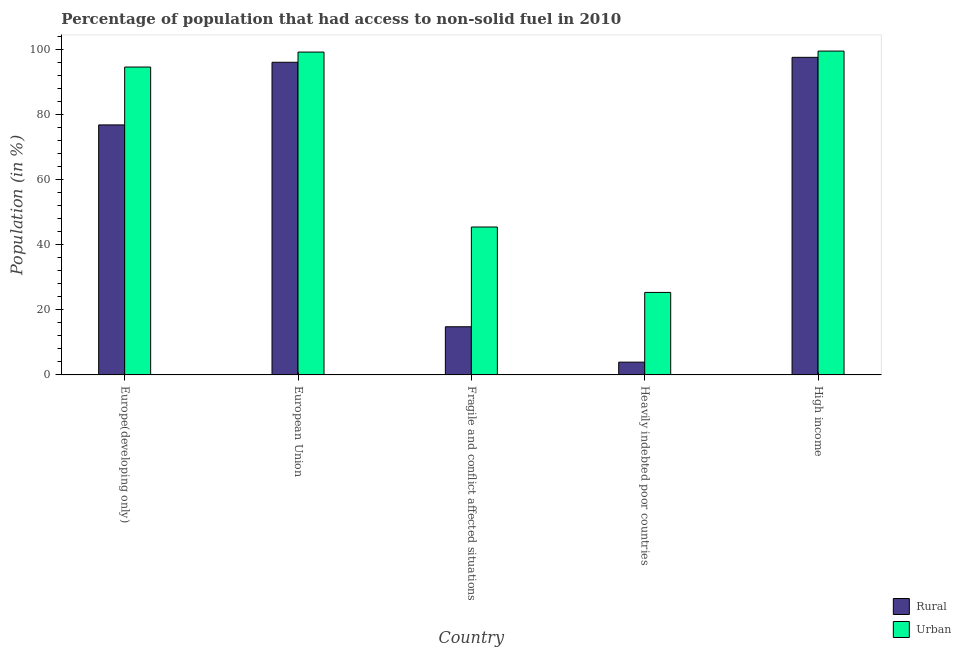How many groups of bars are there?
Your response must be concise. 5. How many bars are there on the 5th tick from the left?
Your answer should be very brief. 2. How many bars are there on the 5th tick from the right?
Your answer should be compact. 2. What is the urban population in European Union?
Keep it short and to the point. 99.33. Across all countries, what is the maximum urban population?
Your response must be concise. 99.63. Across all countries, what is the minimum rural population?
Keep it short and to the point. 3.93. In which country was the urban population maximum?
Offer a terse response. High income. In which country was the urban population minimum?
Keep it short and to the point. Heavily indebted poor countries. What is the total rural population in the graph?
Make the answer very short. 289.55. What is the difference between the urban population in European Union and that in Heavily indebted poor countries?
Offer a very short reply. 73.95. What is the difference between the urban population in European Union and the rural population in High income?
Offer a terse response. 1.62. What is the average rural population per country?
Provide a short and direct response. 57.91. What is the difference between the urban population and rural population in Fragile and conflict affected situations?
Give a very brief answer. 30.69. What is the ratio of the urban population in Fragile and conflict affected situations to that in High income?
Ensure brevity in your answer.  0.46. Is the difference between the urban population in European Union and Fragile and conflict affected situations greater than the difference between the rural population in European Union and Fragile and conflict affected situations?
Keep it short and to the point. No. What is the difference between the highest and the second highest urban population?
Offer a very short reply. 0.31. What is the difference between the highest and the lowest rural population?
Provide a short and direct response. 93.78. In how many countries, is the urban population greater than the average urban population taken over all countries?
Keep it short and to the point. 3. Is the sum of the rural population in Europe(developing only) and European Union greater than the maximum urban population across all countries?
Provide a short and direct response. Yes. What does the 1st bar from the left in Europe(developing only) represents?
Offer a terse response. Rural. What does the 2nd bar from the right in High income represents?
Offer a very short reply. Rural. Are all the bars in the graph horizontal?
Give a very brief answer. No. How many countries are there in the graph?
Keep it short and to the point. 5. Are the values on the major ticks of Y-axis written in scientific E-notation?
Provide a short and direct response. No. Does the graph contain any zero values?
Offer a very short reply. No. Where does the legend appear in the graph?
Ensure brevity in your answer.  Bottom right. How many legend labels are there?
Give a very brief answer. 2. How are the legend labels stacked?
Provide a short and direct response. Vertical. What is the title of the graph?
Give a very brief answer. Percentage of population that had access to non-solid fuel in 2010. What is the label or title of the X-axis?
Offer a very short reply. Country. What is the Population (in %) of Rural in Europe(developing only)?
Provide a succinct answer. 76.92. What is the Population (in %) in Urban in Europe(developing only)?
Your answer should be compact. 94.72. What is the Population (in %) of Rural in European Union?
Ensure brevity in your answer.  96.19. What is the Population (in %) of Urban in European Union?
Provide a short and direct response. 99.33. What is the Population (in %) in Rural in Fragile and conflict affected situations?
Give a very brief answer. 14.82. What is the Population (in %) of Urban in Fragile and conflict affected situations?
Ensure brevity in your answer.  45.51. What is the Population (in %) of Rural in Heavily indebted poor countries?
Provide a succinct answer. 3.93. What is the Population (in %) in Urban in Heavily indebted poor countries?
Provide a succinct answer. 25.38. What is the Population (in %) in Rural in High income?
Your answer should be very brief. 97.7. What is the Population (in %) of Urban in High income?
Offer a very short reply. 99.63. Across all countries, what is the maximum Population (in %) of Rural?
Your answer should be very brief. 97.7. Across all countries, what is the maximum Population (in %) in Urban?
Provide a short and direct response. 99.63. Across all countries, what is the minimum Population (in %) in Rural?
Your response must be concise. 3.93. Across all countries, what is the minimum Population (in %) of Urban?
Provide a short and direct response. 25.38. What is the total Population (in %) in Rural in the graph?
Your answer should be very brief. 289.55. What is the total Population (in %) in Urban in the graph?
Your answer should be compact. 364.57. What is the difference between the Population (in %) in Rural in Europe(developing only) and that in European Union?
Give a very brief answer. -19.27. What is the difference between the Population (in %) in Urban in Europe(developing only) and that in European Union?
Provide a short and direct response. -4.6. What is the difference between the Population (in %) in Rural in Europe(developing only) and that in Fragile and conflict affected situations?
Your response must be concise. 62.1. What is the difference between the Population (in %) of Urban in Europe(developing only) and that in Fragile and conflict affected situations?
Your answer should be compact. 49.22. What is the difference between the Population (in %) in Rural in Europe(developing only) and that in Heavily indebted poor countries?
Your response must be concise. 72.99. What is the difference between the Population (in %) of Urban in Europe(developing only) and that in Heavily indebted poor countries?
Offer a very short reply. 69.34. What is the difference between the Population (in %) of Rural in Europe(developing only) and that in High income?
Give a very brief answer. -20.79. What is the difference between the Population (in %) in Urban in Europe(developing only) and that in High income?
Provide a succinct answer. -4.91. What is the difference between the Population (in %) of Rural in European Union and that in Fragile and conflict affected situations?
Your response must be concise. 81.37. What is the difference between the Population (in %) of Urban in European Union and that in Fragile and conflict affected situations?
Make the answer very short. 53.82. What is the difference between the Population (in %) of Rural in European Union and that in Heavily indebted poor countries?
Ensure brevity in your answer.  92.26. What is the difference between the Population (in %) of Urban in European Union and that in Heavily indebted poor countries?
Your answer should be compact. 73.95. What is the difference between the Population (in %) of Rural in European Union and that in High income?
Ensure brevity in your answer.  -1.52. What is the difference between the Population (in %) in Urban in European Union and that in High income?
Keep it short and to the point. -0.31. What is the difference between the Population (in %) in Rural in Fragile and conflict affected situations and that in Heavily indebted poor countries?
Give a very brief answer. 10.89. What is the difference between the Population (in %) in Urban in Fragile and conflict affected situations and that in Heavily indebted poor countries?
Ensure brevity in your answer.  20.13. What is the difference between the Population (in %) of Rural in Fragile and conflict affected situations and that in High income?
Your response must be concise. -82.89. What is the difference between the Population (in %) of Urban in Fragile and conflict affected situations and that in High income?
Give a very brief answer. -54.13. What is the difference between the Population (in %) of Rural in Heavily indebted poor countries and that in High income?
Keep it short and to the point. -93.78. What is the difference between the Population (in %) in Urban in Heavily indebted poor countries and that in High income?
Your answer should be compact. -74.26. What is the difference between the Population (in %) of Rural in Europe(developing only) and the Population (in %) of Urban in European Union?
Give a very brief answer. -22.41. What is the difference between the Population (in %) of Rural in Europe(developing only) and the Population (in %) of Urban in Fragile and conflict affected situations?
Your answer should be compact. 31.41. What is the difference between the Population (in %) of Rural in Europe(developing only) and the Population (in %) of Urban in Heavily indebted poor countries?
Your answer should be very brief. 51.54. What is the difference between the Population (in %) of Rural in Europe(developing only) and the Population (in %) of Urban in High income?
Your response must be concise. -22.72. What is the difference between the Population (in %) of Rural in European Union and the Population (in %) of Urban in Fragile and conflict affected situations?
Offer a very short reply. 50.68. What is the difference between the Population (in %) of Rural in European Union and the Population (in %) of Urban in Heavily indebted poor countries?
Your answer should be compact. 70.81. What is the difference between the Population (in %) in Rural in European Union and the Population (in %) in Urban in High income?
Give a very brief answer. -3.45. What is the difference between the Population (in %) in Rural in Fragile and conflict affected situations and the Population (in %) in Urban in Heavily indebted poor countries?
Keep it short and to the point. -10.56. What is the difference between the Population (in %) of Rural in Fragile and conflict affected situations and the Population (in %) of Urban in High income?
Provide a succinct answer. -84.82. What is the difference between the Population (in %) of Rural in Heavily indebted poor countries and the Population (in %) of Urban in High income?
Give a very brief answer. -95.71. What is the average Population (in %) in Rural per country?
Keep it short and to the point. 57.91. What is the average Population (in %) of Urban per country?
Provide a short and direct response. 72.91. What is the difference between the Population (in %) of Rural and Population (in %) of Urban in Europe(developing only)?
Your answer should be very brief. -17.81. What is the difference between the Population (in %) of Rural and Population (in %) of Urban in European Union?
Provide a short and direct response. -3.14. What is the difference between the Population (in %) in Rural and Population (in %) in Urban in Fragile and conflict affected situations?
Your response must be concise. -30.69. What is the difference between the Population (in %) of Rural and Population (in %) of Urban in Heavily indebted poor countries?
Ensure brevity in your answer.  -21.45. What is the difference between the Population (in %) in Rural and Population (in %) in Urban in High income?
Your answer should be compact. -1.93. What is the ratio of the Population (in %) in Rural in Europe(developing only) to that in European Union?
Your answer should be compact. 0.8. What is the ratio of the Population (in %) in Urban in Europe(developing only) to that in European Union?
Make the answer very short. 0.95. What is the ratio of the Population (in %) in Rural in Europe(developing only) to that in Fragile and conflict affected situations?
Your response must be concise. 5.19. What is the ratio of the Population (in %) of Urban in Europe(developing only) to that in Fragile and conflict affected situations?
Make the answer very short. 2.08. What is the ratio of the Population (in %) of Rural in Europe(developing only) to that in Heavily indebted poor countries?
Offer a very short reply. 19.59. What is the ratio of the Population (in %) of Urban in Europe(developing only) to that in Heavily indebted poor countries?
Make the answer very short. 3.73. What is the ratio of the Population (in %) in Rural in Europe(developing only) to that in High income?
Ensure brevity in your answer.  0.79. What is the ratio of the Population (in %) in Urban in Europe(developing only) to that in High income?
Provide a succinct answer. 0.95. What is the ratio of the Population (in %) of Rural in European Union to that in Fragile and conflict affected situations?
Ensure brevity in your answer.  6.49. What is the ratio of the Population (in %) in Urban in European Union to that in Fragile and conflict affected situations?
Your response must be concise. 2.18. What is the ratio of the Population (in %) of Rural in European Union to that in Heavily indebted poor countries?
Your response must be concise. 24.49. What is the ratio of the Population (in %) in Urban in European Union to that in Heavily indebted poor countries?
Your answer should be compact. 3.91. What is the ratio of the Population (in %) of Rural in European Union to that in High income?
Make the answer very short. 0.98. What is the ratio of the Population (in %) of Urban in European Union to that in High income?
Ensure brevity in your answer.  1. What is the ratio of the Population (in %) of Rural in Fragile and conflict affected situations to that in Heavily indebted poor countries?
Provide a succinct answer. 3.77. What is the ratio of the Population (in %) in Urban in Fragile and conflict affected situations to that in Heavily indebted poor countries?
Keep it short and to the point. 1.79. What is the ratio of the Population (in %) of Rural in Fragile and conflict affected situations to that in High income?
Your answer should be compact. 0.15. What is the ratio of the Population (in %) of Urban in Fragile and conflict affected situations to that in High income?
Give a very brief answer. 0.46. What is the ratio of the Population (in %) of Rural in Heavily indebted poor countries to that in High income?
Your answer should be compact. 0.04. What is the ratio of the Population (in %) of Urban in Heavily indebted poor countries to that in High income?
Provide a succinct answer. 0.25. What is the difference between the highest and the second highest Population (in %) of Rural?
Your answer should be very brief. 1.52. What is the difference between the highest and the second highest Population (in %) of Urban?
Provide a short and direct response. 0.31. What is the difference between the highest and the lowest Population (in %) of Rural?
Your answer should be compact. 93.78. What is the difference between the highest and the lowest Population (in %) of Urban?
Provide a succinct answer. 74.26. 